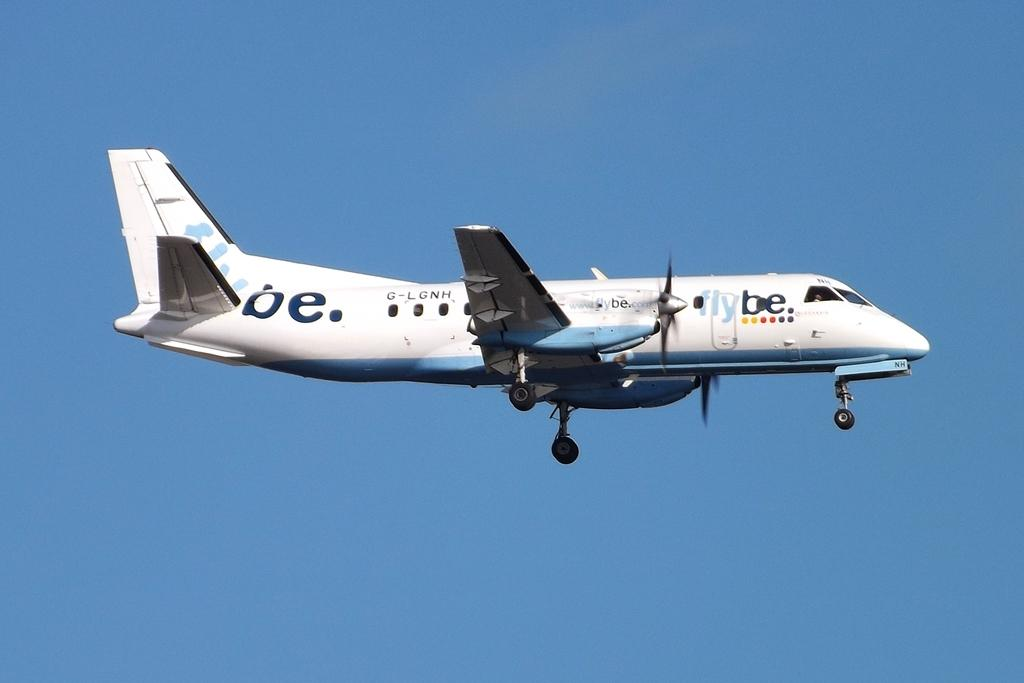What is the main subject of the image? The main subject of the image is an airplane. What is the airplane doing in the image? The airplane is flying in the image. What can be seen in the background of the image? The sky is visible in the background of the image. What type of spark can be seen coming from the airplane's engine in the image? There is no spark visible coming from the airplane's engine in the image. 